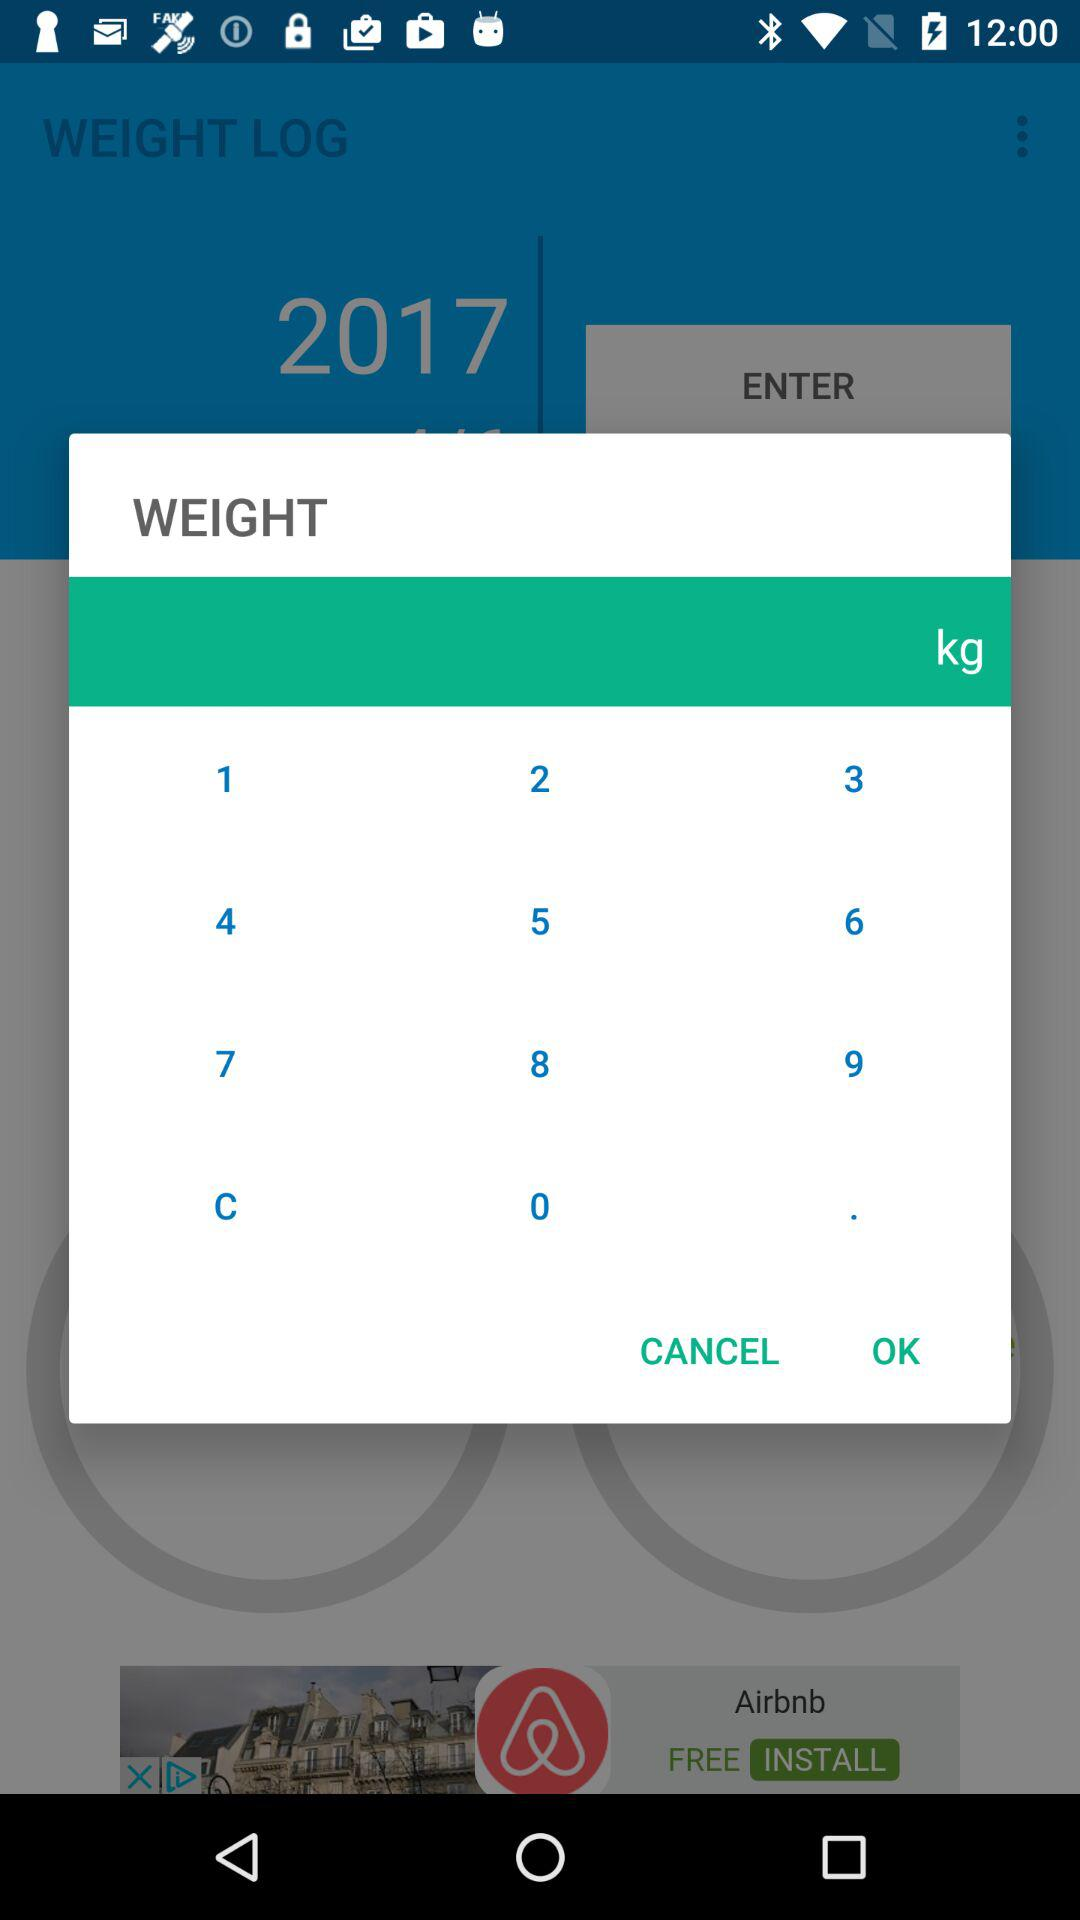What is the unit of weight? The unit of weight is kg. 